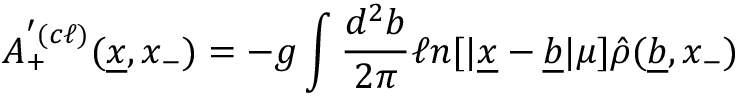<formula> <loc_0><loc_0><loc_500><loc_500>A _ { + } ^ { ^ { \prime } ( c \ell ) } ( \underline { x } , x _ { - } ) = - g \int { \frac { d ^ { 2 } b } { 2 \pi } } \ell n [ | \underline { x } - \underline { b } | \mu ] \hat { \rho } ( \underline { b } , x _ { - } )</formula> 